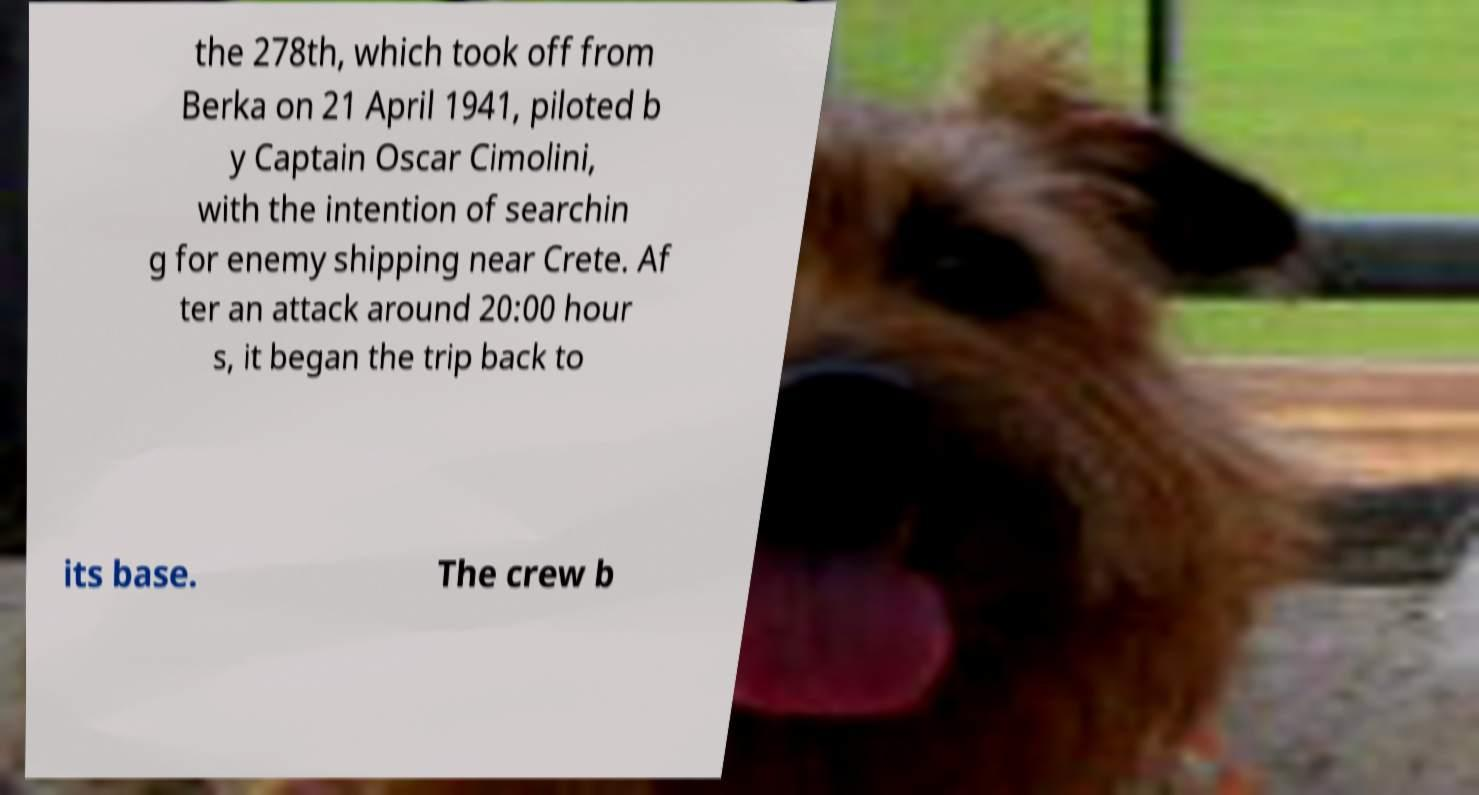There's text embedded in this image that I need extracted. Can you transcribe it verbatim? the 278th, which took off from Berka on 21 April 1941, piloted b y Captain Oscar Cimolini, with the intention of searchin g for enemy shipping near Crete. Af ter an attack around 20:00 hour s, it began the trip back to its base. The crew b 